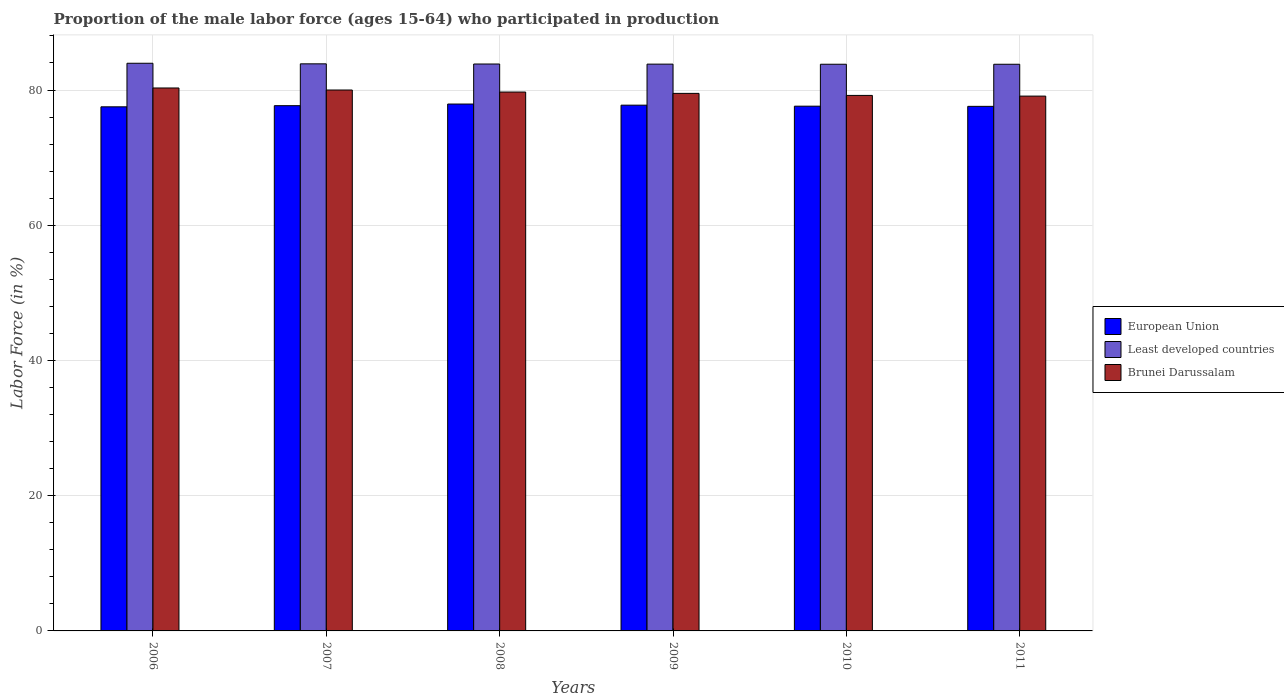Are the number of bars on each tick of the X-axis equal?
Keep it short and to the point. Yes. What is the label of the 5th group of bars from the left?
Your answer should be very brief. 2010. What is the proportion of the male labor force who participated in production in Least developed countries in 2011?
Provide a succinct answer. 83.81. Across all years, what is the maximum proportion of the male labor force who participated in production in Least developed countries?
Ensure brevity in your answer.  83.96. Across all years, what is the minimum proportion of the male labor force who participated in production in Least developed countries?
Offer a terse response. 83.81. In which year was the proportion of the male labor force who participated in production in Least developed countries maximum?
Your answer should be compact. 2006. What is the total proportion of the male labor force who participated in production in Least developed countries in the graph?
Ensure brevity in your answer.  503.12. What is the difference between the proportion of the male labor force who participated in production in European Union in 2007 and that in 2011?
Your answer should be compact. 0.1. What is the difference between the proportion of the male labor force who participated in production in Least developed countries in 2008 and the proportion of the male labor force who participated in production in European Union in 2009?
Your answer should be compact. 6.09. What is the average proportion of the male labor force who participated in production in Least developed countries per year?
Give a very brief answer. 83.85. In the year 2008, what is the difference between the proportion of the male labor force who participated in production in Brunei Darussalam and proportion of the male labor force who participated in production in Least developed countries?
Give a very brief answer. -4.15. In how many years, is the proportion of the male labor force who participated in production in Least developed countries greater than 48 %?
Ensure brevity in your answer.  6. What is the ratio of the proportion of the male labor force who participated in production in European Union in 2006 to that in 2011?
Offer a very short reply. 1. Is the proportion of the male labor force who participated in production in Brunei Darussalam in 2010 less than that in 2011?
Offer a very short reply. No. What is the difference between the highest and the second highest proportion of the male labor force who participated in production in Brunei Darussalam?
Offer a terse response. 0.3. What is the difference between the highest and the lowest proportion of the male labor force who participated in production in European Union?
Your answer should be very brief. 0.41. In how many years, is the proportion of the male labor force who participated in production in Brunei Darussalam greater than the average proportion of the male labor force who participated in production in Brunei Darussalam taken over all years?
Offer a terse response. 3. Is the sum of the proportion of the male labor force who participated in production in Brunei Darussalam in 2007 and 2011 greater than the maximum proportion of the male labor force who participated in production in Least developed countries across all years?
Your answer should be compact. Yes. What does the 1st bar from the right in 2011 represents?
Your response must be concise. Brunei Darussalam. How many bars are there?
Offer a very short reply. 18. Are all the bars in the graph horizontal?
Offer a terse response. No. What is the difference between two consecutive major ticks on the Y-axis?
Offer a very short reply. 20. Where does the legend appear in the graph?
Provide a short and direct response. Center right. What is the title of the graph?
Offer a very short reply. Proportion of the male labor force (ages 15-64) who participated in production. Does "Palau" appear as one of the legend labels in the graph?
Ensure brevity in your answer.  No. What is the label or title of the Y-axis?
Make the answer very short. Labor Force (in %). What is the Labor Force (in %) of European Union in 2006?
Your response must be concise. 77.51. What is the Labor Force (in %) in Least developed countries in 2006?
Give a very brief answer. 83.96. What is the Labor Force (in %) in Brunei Darussalam in 2006?
Your response must be concise. 80.3. What is the Labor Force (in %) in European Union in 2007?
Ensure brevity in your answer.  77.68. What is the Labor Force (in %) in Least developed countries in 2007?
Make the answer very short. 83.87. What is the Labor Force (in %) of Brunei Darussalam in 2007?
Provide a short and direct response. 80. What is the Labor Force (in %) in European Union in 2008?
Provide a succinct answer. 77.93. What is the Labor Force (in %) of Least developed countries in 2008?
Your response must be concise. 83.85. What is the Labor Force (in %) in Brunei Darussalam in 2008?
Give a very brief answer. 79.7. What is the Labor Force (in %) of European Union in 2009?
Offer a very short reply. 77.76. What is the Labor Force (in %) of Least developed countries in 2009?
Offer a very short reply. 83.83. What is the Labor Force (in %) in Brunei Darussalam in 2009?
Make the answer very short. 79.5. What is the Labor Force (in %) of European Union in 2010?
Your answer should be compact. 77.61. What is the Labor Force (in %) in Least developed countries in 2010?
Offer a terse response. 83.81. What is the Labor Force (in %) of Brunei Darussalam in 2010?
Offer a very short reply. 79.2. What is the Labor Force (in %) in European Union in 2011?
Offer a very short reply. 77.58. What is the Labor Force (in %) in Least developed countries in 2011?
Provide a short and direct response. 83.81. What is the Labor Force (in %) in Brunei Darussalam in 2011?
Make the answer very short. 79.1. Across all years, what is the maximum Labor Force (in %) in European Union?
Your response must be concise. 77.93. Across all years, what is the maximum Labor Force (in %) of Least developed countries?
Your response must be concise. 83.96. Across all years, what is the maximum Labor Force (in %) in Brunei Darussalam?
Ensure brevity in your answer.  80.3. Across all years, what is the minimum Labor Force (in %) in European Union?
Your response must be concise. 77.51. Across all years, what is the minimum Labor Force (in %) in Least developed countries?
Your answer should be very brief. 83.81. Across all years, what is the minimum Labor Force (in %) of Brunei Darussalam?
Provide a succinct answer. 79.1. What is the total Labor Force (in %) in European Union in the graph?
Keep it short and to the point. 466.07. What is the total Labor Force (in %) in Least developed countries in the graph?
Your answer should be compact. 503.12. What is the total Labor Force (in %) in Brunei Darussalam in the graph?
Make the answer very short. 477.8. What is the difference between the Labor Force (in %) of European Union in 2006 and that in 2007?
Your answer should be very brief. -0.17. What is the difference between the Labor Force (in %) in Least developed countries in 2006 and that in 2007?
Provide a short and direct response. 0.09. What is the difference between the Labor Force (in %) in Brunei Darussalam in 2006 and that in 2007?
Your answer should be compact. 0.3. What is the difference between the Labor Force (in %) of European Union in 2006 and that in 2008?
Your answer should be very brief. -0.41. What is the difference between the Labor Force (in %) in Least developed countries in 2006 and that in 2008?
Your answer should be compact. 0.11. What is the difference between the Labor Force (in %) in Brunei Darussalam in 2006 and that in 2008?
Ensure brevity in your answer.  0.6. What is the difference between the Labor Force (in %) in European Union in 2006 and that in 2009?
Make the answer very short. -0.24. What is the difference between the Labor Force (in %) in Least developed countries in 2006 and that in 2009?
Your response must be concise. 0.13. What is the difference between the Labor Force (in %) in European Union in 2006 and that in 2010?
Your answer should be very brief. -0.1. What is the difference between the Labor Force (in %) of Least developed countries in 2006 and that in 2010?
Offer a terse response. 0.15. What is the difference between the Labor Force (in %) of Brunei Darussalam in 2006 and that in 2010?
Your answer should be compact. 1.1. What is the difference between the Labor Force (in %) in European Union in 2006 and that in 2011?
Your response must be concise. -0.07. What is the difference between the Labor Force (in %) of Least developed countries in 2006 and that in 2011?
Offer a terse response. 0.15. What is the difference between the Labor Force (in %) of Brunei Darussalam in 2006 and that in 2011?
Your answer should be compact. 1.2. What is the difference between the Labor Force (in %) of European Union in 2007 and that in 2008?
Give a very brief answer. -0.24. What is the difference between the Labor Force (in %) of Least developed countries in 2007 and that in 2008?
Provide a short and direct response. 0.02. What is the difference between the Labor Force (in %) in Brunei Darussalam in 2007 and that in 2008?
Your answer should be very brief. 0.3. What is the difference between the Labor Force (in %) of European Union in 2007 and that in 2009?
Your response must be concise. -0.08. What is the difference between the Labor Force (in %) of Least developed countries in 2007 and that in 2009?
Make the answer very short. 0.04. What is the difference between the Labor Force (in %) in European Union in 2007 and that in 2010?
Make the answer very short. 0.07. What is the difference between the Labor Force (in %) of Least developed countries in 2007 and that in 2010?
Your response must be concise. 0.06. What is the difference between the Labor Force (in %) of Brunei Darussalam in 2007 and that in 2010?
Offer a terse response. 0.8. What is the difference between the Labor Force (in %) of European Union in 2007 and that in 2011?
Offer a terse response. 0.1. What is the difference between the Labor Force (in %) in Least developed countries in 2007 and that in 2011?
Your answer should be very brief. 0.06. What is the difference between the Labor Force (in %) in Brunei Darussalam in 2007 and that in 2011?
Offer a very short reply. 0.9. What is the difference between the Labor Force (in %) of European Union in 2008 and that in 2009?
Make the answer very short. 0.17. What is the difference between the Labor Force (in %) of Least developed countries in 2008 and that in 2009?
Offer a terse response. 0.02. What is the difference between the Labor Force (in %) in European Union in 2008 and that in 2010?
Your answer should be compact. 0.32. What is the difference between the Labor Force (in %) of Least developed countries in 2008 and that in 2010?
Make the answer very short. 0.04. What is the difference between the Labor Force (in %) in European Union in 2008 and that in 2011?
Keep it short and to the point. 0.34. What is the difference between the Labor Force (in %) in Least developed countries in 2008 and that in 2011?
Make the answer very short. 0.04. What is the difference between the Labor Force (in %) in Brunei Darussalam in 2008 and that in 2011?
Offer a very short reply. 0.6. What is the difference between the Labor Force (in %) in European Union in 2009 and that in 2010?
Provide a succinct answer. 0.15. What is the difference between the Labor Force (in %) in Least developed countries in 2009 and that in 2010?
Offer a terse response. 0.02. What is the difference between the Labor Force (in %) in Brunei Darussalam in 2009 and that in 2010?
Make the answer very short. 0.3. What is the difference between the Labor Force (in %) of European Union in 2009 and that in 2011?
Give a very brief answer. 0.18. What is the difference between the Labor Force (in %) in Least developed countries in 2009 and that in 2011?
Offer a very short reply. 0.02. What is the difference between the Labor Force (in %) of European Union in 2010 and that in 2011?
Provide a short and direct response. 0.03. What is the difference between the Labor Force (in %) of Least developed countries in 2010 and that in 2011?
Your response must be concise. 0. What is the difference between the Labor Force (in %) of European Union in 2006 and the Labor Force (in %) of Least developed countries in 2007?
Your answer should be compact. -6.36. What is the difference between the Labor Force (in %) in European Union in 2006 and the Labor Force (in %) in Brunei Darussalam in 2007?
Offer a very short reply. -2.49. What is the difference between the Labor Force (in %) in Least developed countries in 2006 and the Labor Force (in %) in Brunei Darussalam in 2007?
Provide a succinct answer. 3.96. What is the difference between the Labor Force (in %) of European Union in 2006 and the Labor Force (in %) of Least developed countries in 2008?
Provide a short and direct response. -6.33. What is the difference between the Labor Force (in %) in European Union in 2006 and the Labor Force (in %) in Brunei Darussalam in 2008?
Ensure brevity in your answer.  -2.19. What is the difference between the Labor Force (in %) of Least developed countries in 2006 and the Labor Force (in %) of Brunei Darussalam in 2008?
Ensure brevity in your answer.  4.26. What is the difference between the Labor Force (in %) of European Union in 2006 and the Labor Force (in %) of Least developed countries in 2009?
Offer a terse response. -6.31. What is the difference between the Labor Force (in %) of European Union in 2006 and the Labor Force (in %) of Brunei Darussalam in 2009?
Provide a short and direct response. -1.99. What is the difference between the Labor Force (in %) of Least developed countries in 2006 and the Labor Force (in %) of Brunei Darussalam in 2009?
Your answer should be compact. 4.46. What is the difference between the Labor Force (in %) in European Union in 2006 and the Labor Force (in %) in Least developed countries in 2010?
Give a very brief answer. -6.3. What is the difference between the Labor Force (in %) of European Union in 2006 and the Labor Force (in %) of Brunei Darussalam in 2010?
Make the answer very short. -1.69. What is the difference between the Labor Force (in %) of Least developed countries in 2006 and the Labor Force (in %) of Brunei Darussalam in 2010?
Keep it short and to the point. 4.76. What is the difference between the Labor Force (in %) of European Union in 2006 and the Labor Force (in %) of Least developed countries in 2011?
Give a very brief answer. -6.3. What is the difference between the Labor Force (in %) of European Union in 2006 and the Labor Force (in %) of Brunei Darussalam in 2011?
Ensure brevity in your answer.  -1.59. What is the difference between the Labor Force (in %) of Least developed countries in 2006 and the Labor Force (in %) of Brunei Darussalam in 2011?
Keep it short and to the point. 4.86. What is the difference between the Labor Force (in %) of European Union in 2007 and the Labor Force (in %) of Least developed countries in 2008?
Ensure brevity in your answer.  -6.16. What is the difference between the Labor Force (in %) of European Union in 2007 and the Labor Force (in %) of Brunei Darussalam in 2008?
Offer a very short reply. -2.02. What is the difference between the Labor Force (in %) in Least developed countries in 2007 and the Labor Force (in %) in Brunei Darussalam in 2008?
Ensure brevity in your answer.  4.17. What is the difference between the Labor Force (in %) of European Union in 2007 and the Labor Force (in %) of Least developed countries in 2009?
Your answer should be compact. -6.14. What is the difference between the Labor Force (in %) of European Union in 2007 and the Labor Force (in %) of Brunei Darussalam in 2009?
Provide a succinct answer. -1.82. What is the difference between the Labor Force (in %) in Least developed countries in 2007 and the Labor Force (in %) in Brunei Darussalam in 2009?
Offer a very short reply. 4.37. What is the difference between the Labor Force (in %) of European Union in 2007 and the Labor Force (in %) of Least developed countries in 2010?
Your answer should be very brief. -6.13. What is the difference between the Labor Force (in %) of European Union in 2007 and the Labor Force (in %) of Brunei Darussalam in 2010?
Keep it short and to the point. -1.52. What is the difference between the Labor Force (in %) in Least developed countries in 2007 and the Labor Force (in %) in Brunei Darussalam in 2010?
Your response must be concise. 4.67. What is the difference between the Labor Force (in %) in European Union in 2007 and the Labor Force (in %) in Least developed countries in 2011?
Ensure brevity in your answer.  -6.13. What is the difference between the Labor Force (in %) of European Union in 2007 and the Labor Force (in %) of Brunei Darussalam in 2011?
Make the answer very short. -1.42. What is the difference between the Labor Force (in %) in Least developed countries in 2007 and the Labor Force (in %) in Brunei Darussalam in 2011?
Your response must be concise. 4.77. What is the difference between the Labor Force (in %) of European Union in 2008 and the Labor Force (in %) of Least developed countries in 2009?
Provide a succinct answer. -5.9. What is the difference between the Labor Force (in %) in European Union in 2008 and the Labor Force (in %) in Brunei Darussalam in 2009?
Ensure brevity in your answer.  -1.57. What is the difference between the Labor Force (in %) in Least developed countries in 2008 and the Labor Force (in %) in Brunei Darussalam in 2009?
Offer a very short reply. 4.35. What is the difference between the Labor Force (in %) of European Union in 2008 and the Labor Force (in %) of Least developed countries in 2010?
Keep it short and to the point. -5.88. What is the difference between the Labor Force (in %) of European Union in 2008 and the Labor Force (in %) of Brunei Darussalam in 2010?
Ensure brevity in your answer.  -1.27. What is the difference between the Labor Force (in %) of Least developed countries in 2008 and the Labor Force (in %) of Brunei Darussalam in 2010?
Provide a short and direct response. 4.65. What is the difference between the Labor Force (in %) in European Union in 2008 and the Labor Force (in %) in Least developed countries in 2011?
Your response must be concise. -5.88. What is the difference between the Labor Force (in %) of European Union in 2008 and the Labor Force (in %) of Brunei Darussalam in 2011?
Make the answer very short. -1.17. What is the difference between the Labor Force (in %) of Least developed countries in 2008 and the Labor Force (in %) of Brunei Darussalam in 2011?
Your answer should be very brief. 4.75. What is the difference between the Labor Force (in %) in European Union in 2009 and the Labor Force (in %) in Least developed countries in 2010?
Your answer should be very brief. -6.05. What is the difference between the Labor Force (in %) in European Union in 2009 and the Labor Force (in %) in Brunei Darussalam in 2010?
Offer a terse response. -1.44. What is the difference between the Labor Force (in %) of Least developed countries in 2009 and the Labor Force (in %) of Brunei Darussalam in 2010?
Provide a short and direct response. 4.63. What is the difference between the Labor Force (in %) of European Union in 2009 and the Labor Force (in %) of Least developed countries in 2011?
Your answer should be compact. -6.05. What is the difference between the Labor Force (in %) in European Union in 2009 and the Labor Force (in %) in Brunei Darussalam in 2011?
Give a very brief answer. -1.34. What is the difference between the Labor Force (in %) of Least developed countries in 2009 and the Labor Force (in %) of Brunei Darussalam in 2011?
Make the answer very short. 4.73. What is the difference between the Labor Force (in %) of European Union in 2010 and the Labor Force (in %) of Least developed countries in 2011?
Your answer should be very brief. -6.2. What is the difference between the Labor Force (in %) in European Union in 2010 and the Labor Force (in %) in Brunei Darussalam in 2011?
Make the answer very short. -1.49. What is the difference between the Labor Force (in %) in Least developed countries in 2010 and the Labor Force (in %) in Brunei Darussalam in 2011?
Keep it short and to the point. 4.71. What is the average Labor Force (in %) in European Union per year?
Provide a succinct answer. 77.68. What is the average Labor Force (in %) of Least developed countries per year?
Keep it short and to the point. 83.85. What is the average Labor Force (in %) in Brunei Darussalam per year?
Provide a succinct answer. 79.63. In the year 2006, what is the difference between the Labor Force (in %) of European Union and Labor Force (in %) of Least developed countries?
Your response must be concise. -6.44. In the year 2006, what is the difference between the Labor Force (in %) of European Union and Labor Force (in %) of Brunei Darussalam?
Make the answer very short. -2.79. In the year 2006, what is the difference between the Labor Force (in %) of Least developed countries and Labor Force (in %) of Brunei Darussalam?
Offer a terse response. 3.66. In the year 2007, what is the difference between the Labor Force (in %) in European Union and Labor Force (in %) in Least developed countries?
Offer a terse response. -6.19. In the year 2007, what is the difference between the Labor Force (in %) of European Union and Labor Force (in %) of Brunei Darussalam?
Make the answer very short. -2.32. In the year 2007, what is the difference between the Labor Force (in %) of Least developed countries and Labor Force (in %) of Brunei Darussalam?
Give a very brief answer. 3.87. In the year 2008, what is the difference between the Labor Force (in %) in European Union and Labor Force (in %) in Least developed countries?
Ensure brevity in your answer.  -5.92. In the year 2008, what is the difference between the Labor Force (in %) in European Union and Labor Force (in %) in Brunei Darussalam?
Keep it short and to the point. -1.77. In the year 2008, what is the difference between the Labor Force (in %) of Least developed countries and Labor Force (in %) of Brunei Darussalam?
Your response must be concise. 4.15. In the year 2009, what is the difference between the Labor Force (in %) in European Union and Labor Force (in %) in Least developed countries?
Keep it short and to the point. -6.07. In the year 2009, what is the difference between the Labor Force (in %) in European Union and Labor Force (in %) in Brunei Darussalam?
Your response must be concise. -1.74. In the year 2009, what is the difference between the Labor Force (in %) of Least developed countries and Labor Force (in %) of Brunei Darussalam?
Ensure brevity in your answer.  4.33. In the year 2010, what is the difference between the Labor Force (in %) in European Union and Labor Force (in %) in Least developed countries?
Keep it short and to the point. -6.2. In the year 2010, what is the difference between the Labor Force (in %) in European Union and Labor Force (in %) in Brunei Darussalam?
Provide a short and direct response. -1.59. In the year 2010, what is the difference between the Labor Force (in %) of Least developed countries and Labor Force (in %) of Brunei Darussalam?
Make the answer very short. 4.61. In the year 2011, what is the difference between the Labor Force (in %) in European Union and Labor Force (in %) in Least developed countries?
Your response must be concise. -6.23. In the year 2011, what is the difference between the Labor Force (in %) in European Union and Labor Force (in %) in Brunei Darussalam?
Your response must be concise. -1.52. In the year 2011, what is the difference between the Labor Force (in %) of Least developed countries and Labor Force (in %) of Brunei Darussalam?
Keep it short and to the point. 4.71. What is the ratio of the Labor Force (in %) of European Union in 2006 to that in 2007?
Provide a succinct answer. 1. What is the ratio of the Labor Force (in %) in Least developed countries in 2006 to that in 2007?
Ensure brevity in your answer.  1. What is the ratio of the Labor Force (in %) in Least developed countries in 2006 to that in 2008?
Your response must be concise. 1. What is the ratio of the Labor Force (in %) in Brunei Darussalam in 2006 to that in 2008?
Keep it short and to the point. 1.01. What is the ratio of the Labor Force (in %) in Brunei Darussalam in 2006 to that in 2009?
Offer a very short reply. 1.01. What is the ratio of the Labor Force (in %) of European Union in 2006 to that in 2010?
Offer a very short reply. 1. What is the ratio of the Labor Force (in %) of Least developed countries in 2006 to that in 2010?
Keep it short and to the point. 1. What is the ratio of the Labor Force (in %) of Brunei Darussalam in 2006 to that in 2010?
Your response must be concise. 1.01. What is the ratio of the Labor Force (in %) of European Union in 2006 to that in 2011?
Offer a very short reply. 1. What is the ratio of the Labor Force (in %) in Least developed countries in 2006 to that in 2011?
Ensure brevity in your answer.  1. What is the ratio of the Labor Force (in %) of Brunei Darussalam in 2006 to that in 2011?
Provide a succinct answer. 1.02. What is the ratio of the Labor Force (in %) in Brunei Darussalam in 2007 to that in 2008?
Provide a succinct answer. 1. What is the ratio of the Labor Force (in %) of Least developed countries in 2007 to that in 2009?
Offer a very short reply. 1. What is the ratio of the Labor Force (in %) of Brunei Darussalam in 2007 to that in 2009?
Ensure brevity in your answer.  1.01. What is the ratio of the Labor Force (in %) of European Union in 2007 to that in 2010?
Your response must be concise. 1. What is the ratio of the Labor Force (in %) of Least developed countries in 2007 to that in 2010?
Your answer should be compact. 1. What is the ratio of the Labor Force (in %) of European Union in 2007 to that in 2011?
Provide a succinct answer. 1. What is the ratio of the Labor Force (in %) in Least developed countries in 2007 to that in 2011?
Offer a terse response. 1. What is the ratio of the Labor Force (in %) in Brunei Darussalam in 2007 to that in 2011?
Your response must be concise. 1.01. What is the ratio of the Labor Force (in %) of Least developed countries in 2008 to that in 2010?
Offer a very short reply. 1. What is the ratio of the Labor Force (in %) of Brunei Darussalam in 2008 to that in 2010?
Keep it short and to the point. 1.01. What is the ratio of the Labor Force (in %) of Brunei Darussalam in 2008 to that in 2011?
Give a very brief answer. 1.01. What is the ratio of the Labor Force (in %) of European Union in 2009 to that in 2010?
Offer a terse response. 1. What is the ratio of the Labor Force (in %) in Least developed countries in 2009 to that in 2010?
Ensure brevity in your answer.  1. What is the ratio of the Labor Force (in %) of Brunei Darussalam in 2009 to that in 2011?
Give a very brief answer. 1.01. What is the ratio of the Labor Force (in %) in European Union in 2010 to that in 2011?
Provide a short and direct response. 1. What is the ratio of the Labor Force (in %) of Least developed countries in 2010 to that in 2011?
Make the answer very short. 1. What is the difference between the highest and the second highest Labor Force (in %) in European Union?
Give a very brief answer. 0.17. What is the difference between the highest and the second highest Labor Force (in %) of Least developed countries?
Give a very brief answer. 0.09. What is the difference between the highest and the second highest Labor Force (in %) in Brunei Darussalam?
Keep it short and to the point. 0.3. What is the difference between the highest and the lowest Labor Force (in %) in European Union?
Offer a very short reply. 0.41. What is the difference between the highest and the lowest Labor Force (in %) of Least developed countries?
Provide a short and direct response. 0.15. What is the difference between the highest and the lowest Labor Force (in %) of Brunei Darussalam?
Make the answer very short. 1.2. 